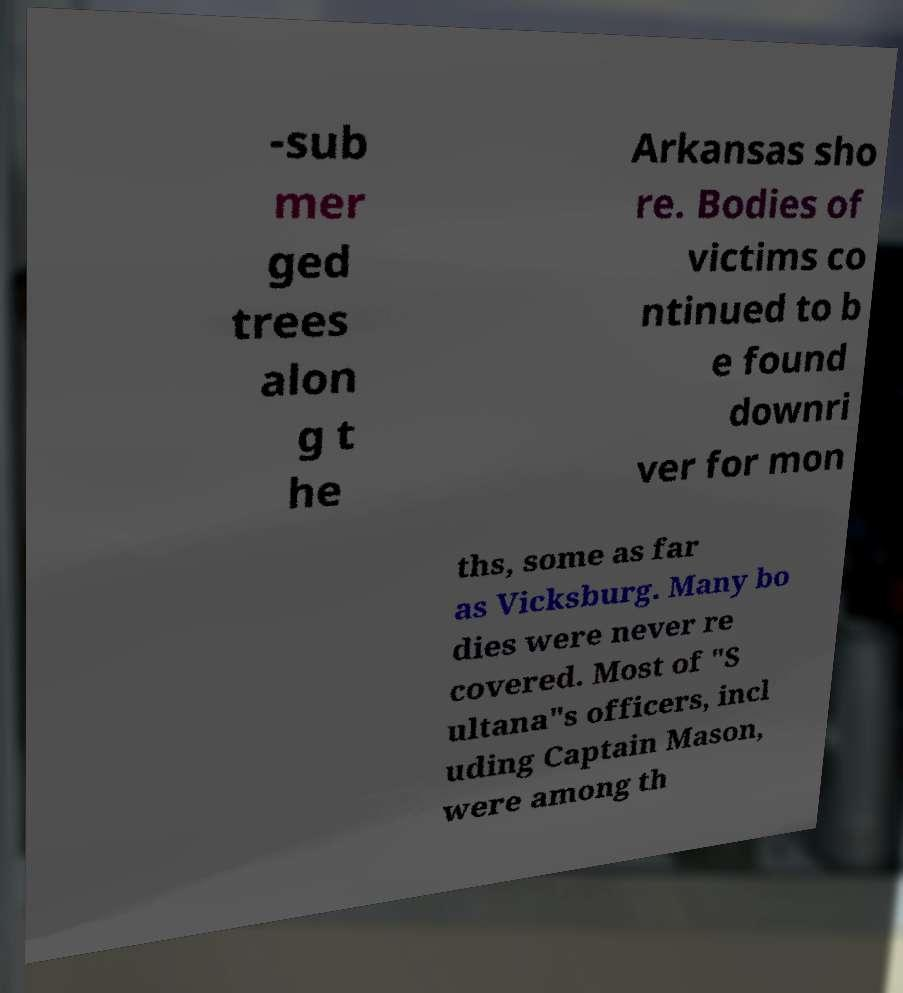Please read and relay the text visible in this image. What does it say? -sub mer ged trees alon g t he Arkansas sho re. Bodies of victims co ntinued to b e found downri ver for mon ths, some as far as Vicksburg. Many bo dies were never re covered. Most of "S ultana"s officers, incl uding Captain Mason, were among th 